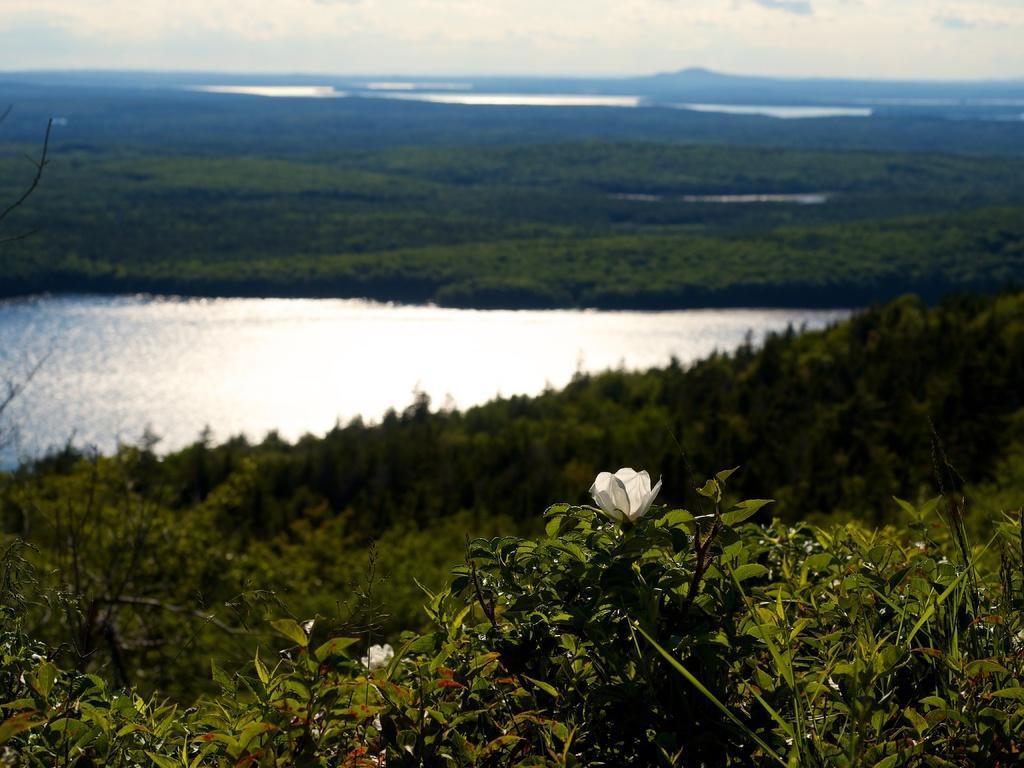Could you give a brief overview of what you see in this image? In the image we can see plants, flower white in color, water and a sky. 